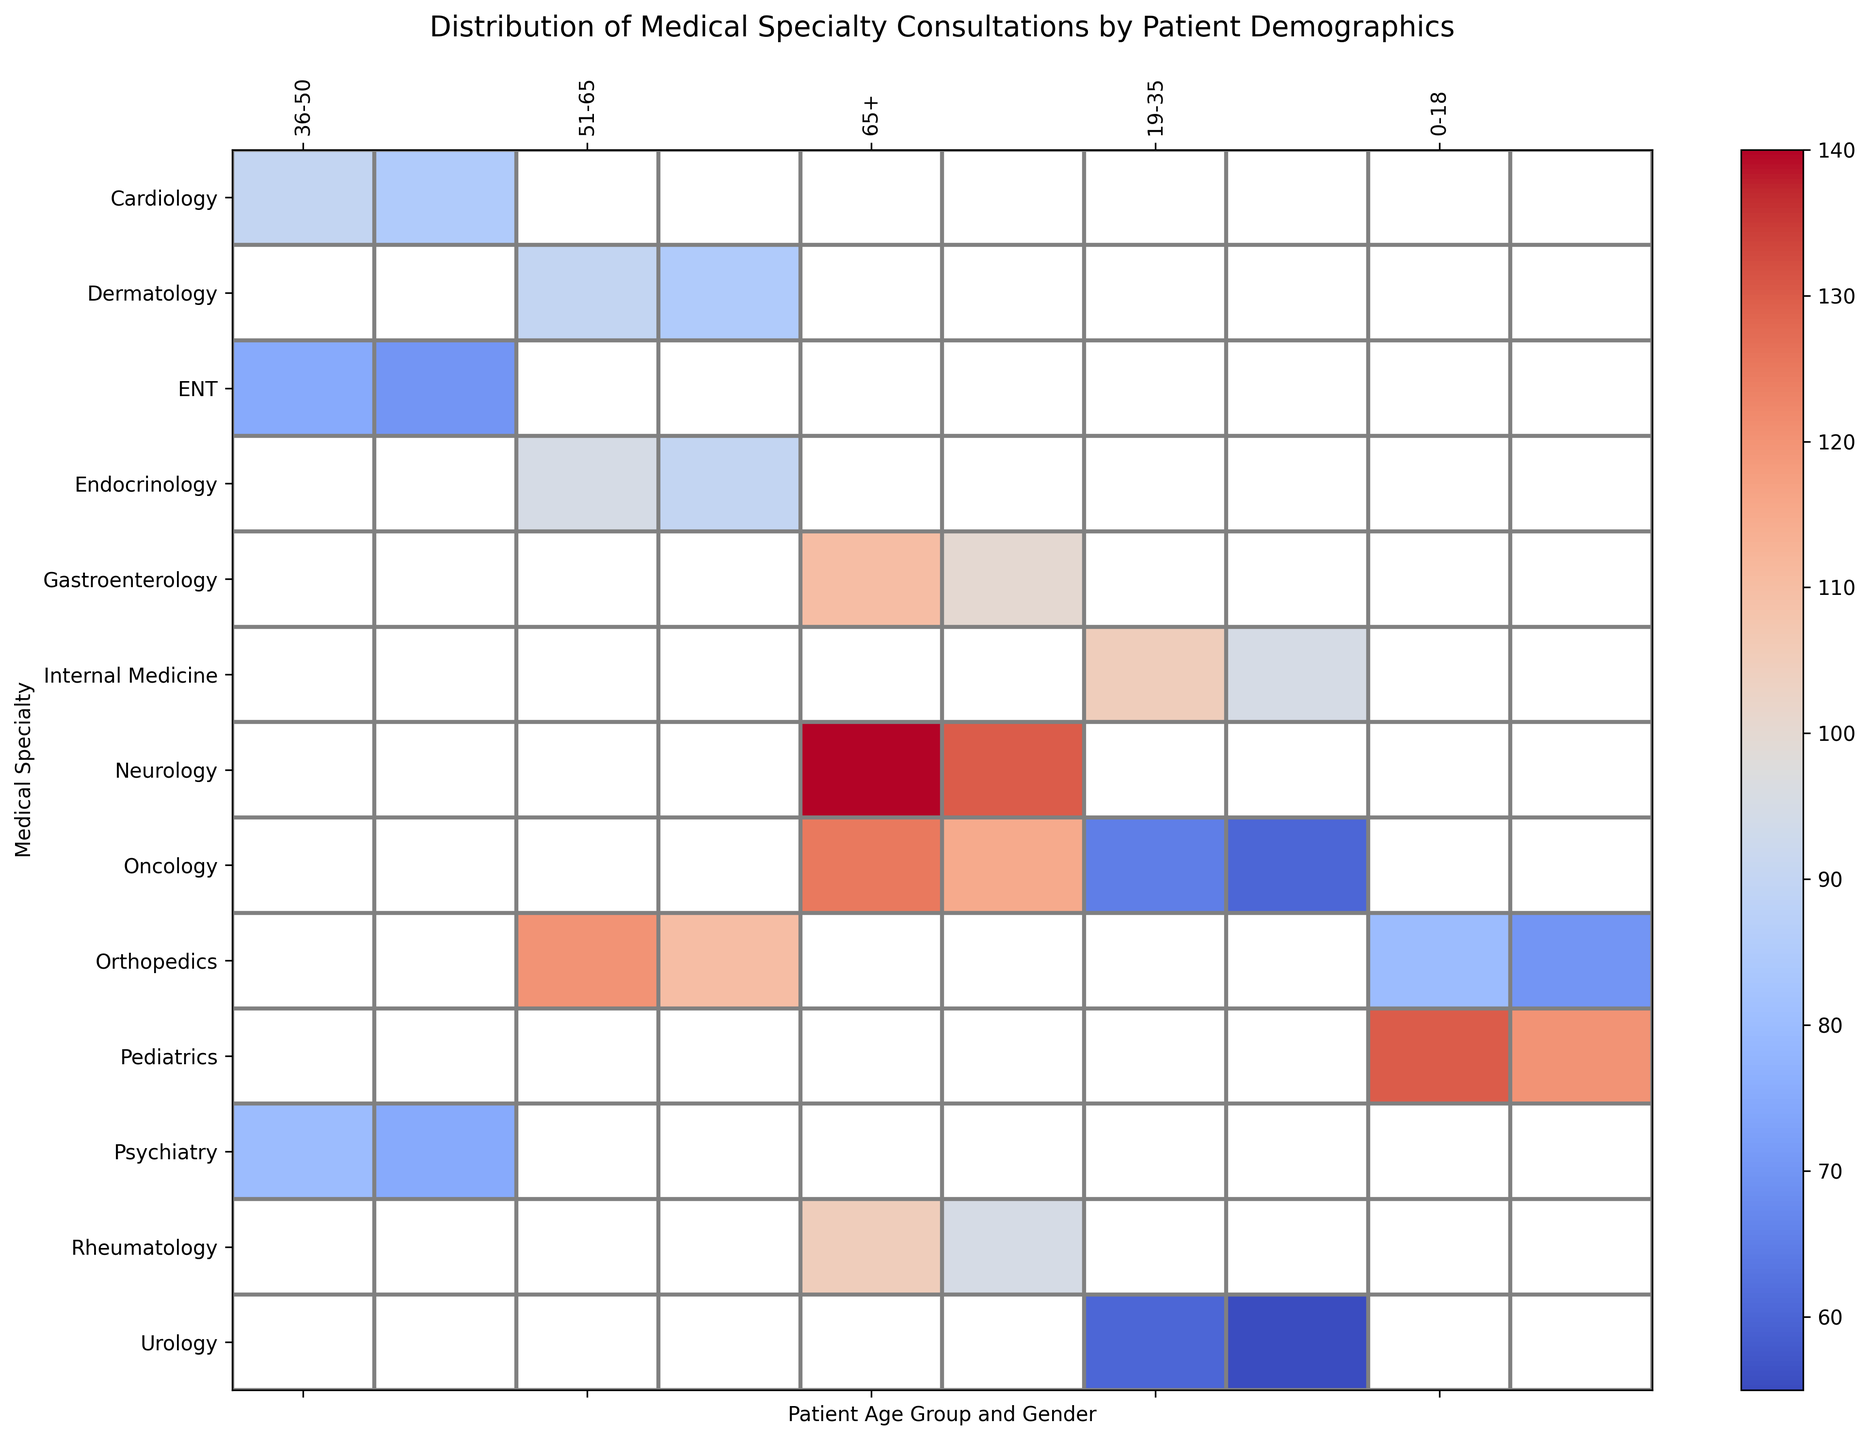What medical specialty has the highest number of consultations among females aged 0-18? Look at the column corresponding to females aged 0-18. The specialty with the highest shade of red or the highest number is Pediatrics with a value of 130.
Answer: Pediatrics Which age group and gender have the lowest number of consultations in Oncology? Look at the row for Oncology and compare the values for each demographic group. The lowest number is for males aged 19-35, with a value of 60.
Answer: 19-35, Male What is the total number of consultations for Cardiology across all age groups and genders? Sum the values for Cardiology in all columns: 85 (M, 36-50) + 90 (F, 36-50) = 175.
Answer: 175 Between males and females aged 65+, who has more consultations in Neurology? Compare the numbers in the Neurology row for males and females aged 65+. Females have 140 consultations, and males have 130.
Answer: Females In the 51-65 age group, which medical specialty sees the greatest difference in the number of consultations between males and females? Compare the differences between males and females in the 51-65 columns for each specialty. The greatest difference is in Orthopedics, with females having 10 more consultations than males.
Answer: Orthopedics What is the average number of consultations for Pediatrics across both males and females aged 0-18? Sum the values for males and females aged 0-18 in Pediatrics and divide by 2: (120 + 130) / 2 = 125.
Answer: 125 Which specialty has more consultations in males aged 65+ than in females aged 65+, and by how much? Compare the values for all specialties in the males and females aged 65+ columns. For all, males have fewer than or equal to females except Neurology and Oncology. Neurology's difference is higher: (140 - 130) = 10.
Answer: Neurology, 10 How many more consultations are there in Gastroenterology for females aged 65+ compared to males aged 65+? Subtract the number of consultations for males from females in Gastroenterology: 110 - 100 = 10.
Answer: 10 What is the color pattern for Cardiology consultations across different age groups and genders? Observe the shade of red for Cardiology across both sexes in age 36-50. Both genders are medium red.
Answer: Medium red For which age group and gender does Orthopedics have exactly 70 consultations? The value 70 appears in columns for males aged 0-18 for Orthopedics.
Answer: 0-18, Male 